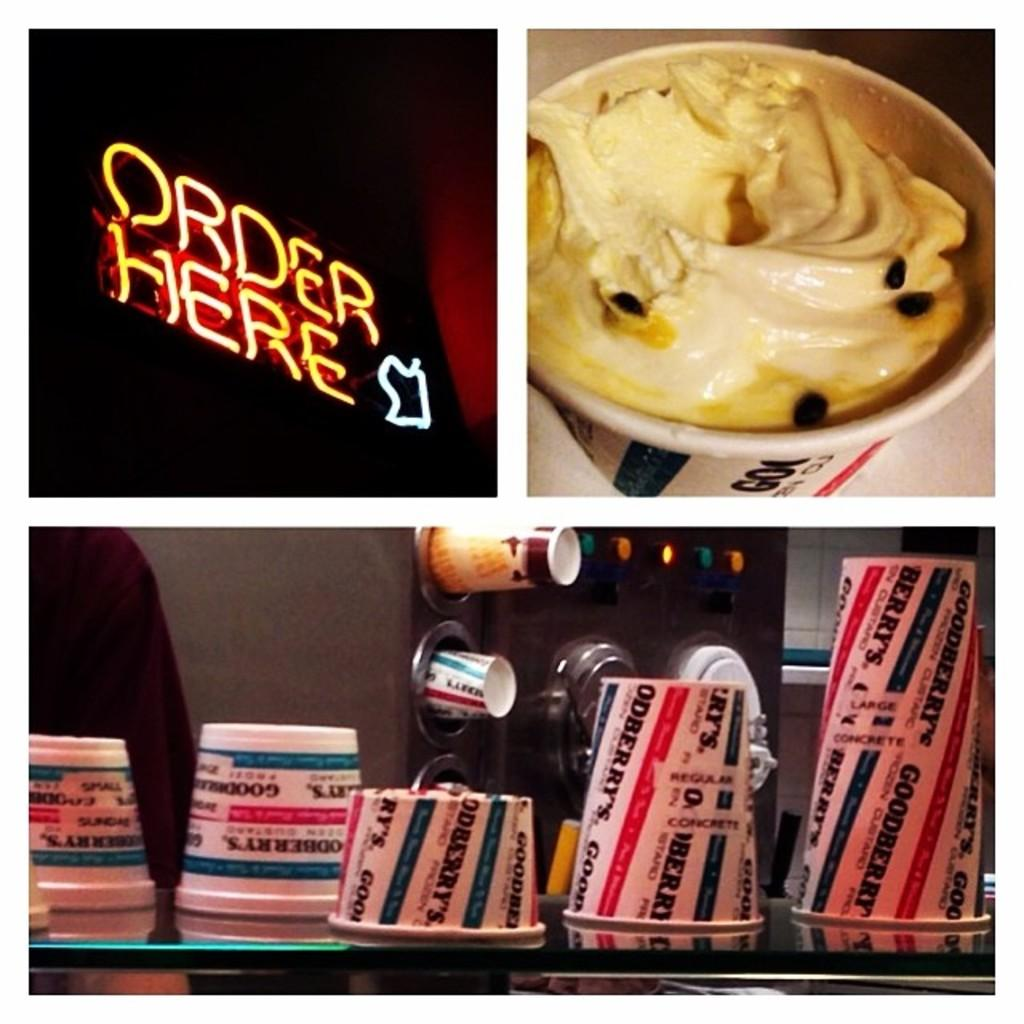<image>
Describe the image concisely. A neon sign is lit up, displaying the phrase "order here" 